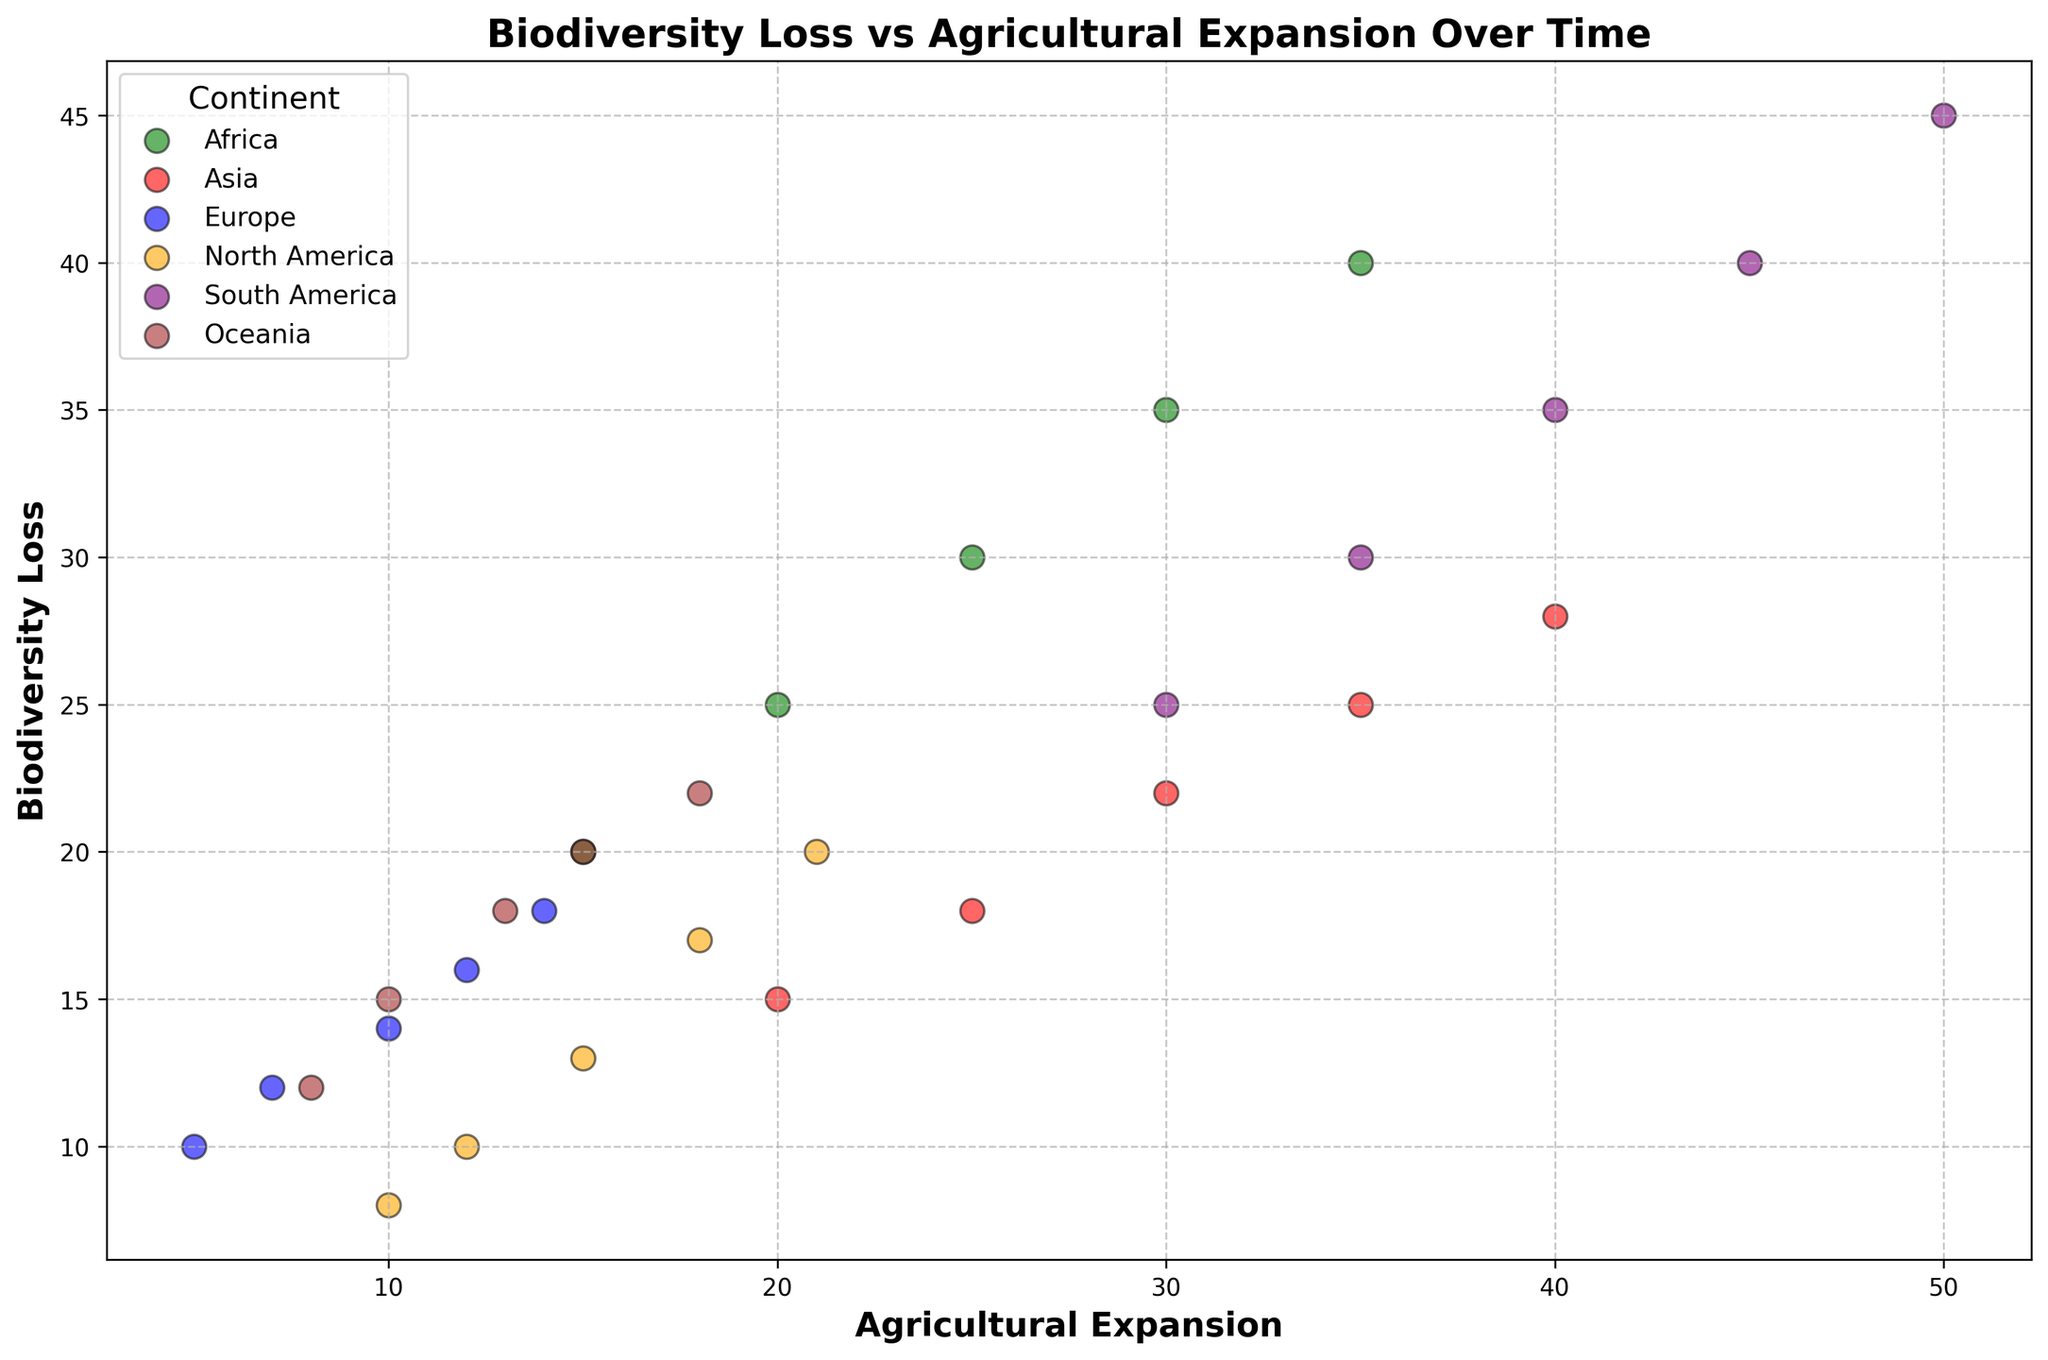Which continent shows the highest biodiversity loss? Look at the y-axis representing biodiversity loss and find the point with the maximum value, which is 45. The point with the highest biodiversity loss is located in South America.
Answer: South America How does biodiversity loss in Europe compare to Asia in 2020? Identify the points representing Europe and Asia in 2020. Europe's biodiversity loss is 18, while Asia's is 28. Comparing these values, Asia has a higher biodiversity loss than Europe in 2020.
Answer: Asia has higher loss Which continent exhibits the lowest agricultural expansion in 1980? Locate the points for each continent in 1980 and examine the x-axis values. North America's agricultural expansion in 1980 is the lowest at 10.
Answer: North America Is there a continent where biodiversity loss and agricultural expansion show a nearly linear relationship? Observe the overall trend of the scatter points for each continent. South America's points form a near-linear pattern, where an increase in agricultural expansion correlates with increased biodiversity loss.
Answer: South America What is the average biodiversity loss over the years for Oceania? Find the biodiversity loss values for Oceania across all years (12, 15, 18, 20, 22). Calculate the average by summing these values and dividing by the number of points. (12 + 15 + 18 + 20 + 22) / 5 = 87 / 5 = 17.4
Answer: 17.4 Between 1980 and 2020, how much did agricultural expansion grow in Africa? Find the agricultural expansion values for Africa in 1980 and 2020. The values are 15 and 35 respectively. The increase is 35 - 15 = 20.
Answer: 20 Which continent's points are depicted using orange color? Refer to the color legend associated with the scatter plot which assigns colors to each continent. North America's points use the orange color.
Answer: North America In 2000, which continent had a higher biodiversity loss, Africa or South America? Locate the points for Africa and South America in the year 2000. Africa's biodiversity loss is 30, while South America's is 35. South America had a higher biodiversity loss.
Answer: South America What are the trends of biodiversity loss in Asia over time? Examine the scatter points for Asia from 1980 to 2020. The biodiversity loss values for Asia are 15, 18, 22, 25, and 28, showing an increasing trend over time.
Answer: Increasing trend Looking at the grid, does any continent display a surprisingly low biodiversity loss for high agricultural expansion? Observe the scatter points for high agricultural expansion (upper right part of the plot). Europe, even at higher agricultural expansion values, maintains relatively low biodiversity loss compared to other continents.
Answer: Europe 